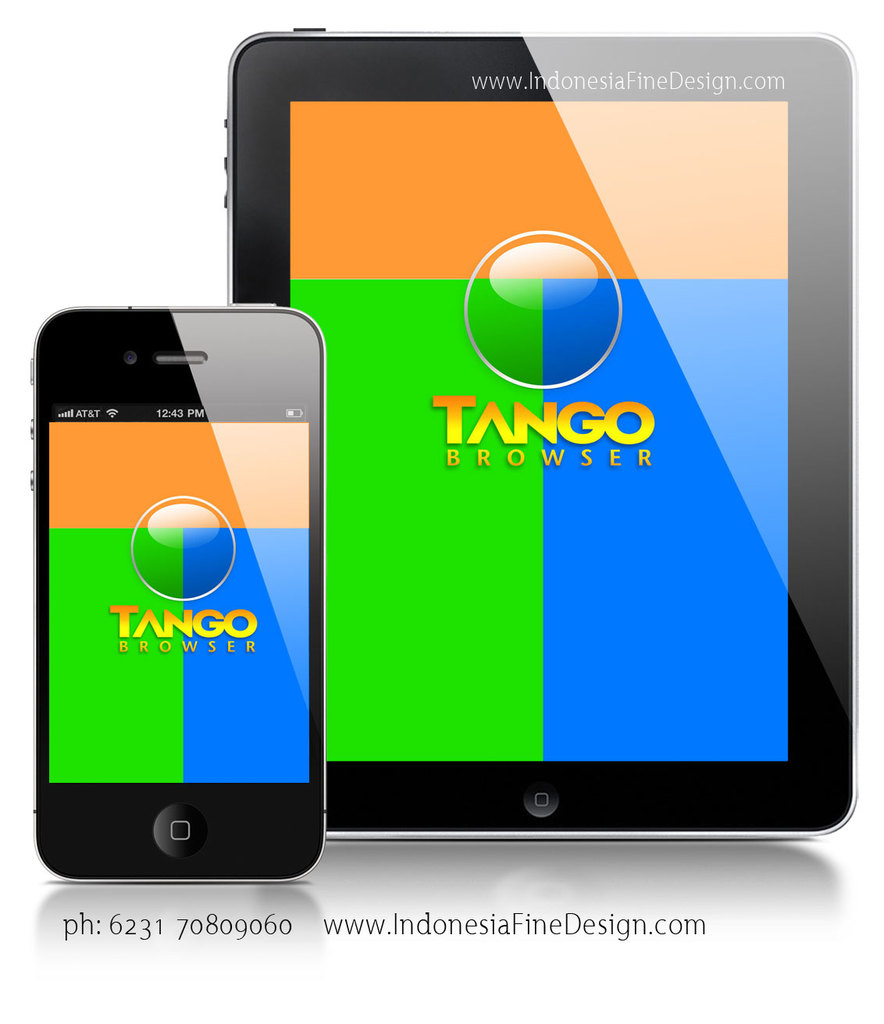What might be the significance of the placement of the logo and text in the advertisement? The central placement of the Tango Browser logo and the text on both devices within the image ensures that they are immediately visible to viewers, emphasizing brand recognition. The logo is prominently featured to associate the vibrant color scheme directly with the brand, while the contact information is clearly displayed to encourage direct engagement from prospective users. 